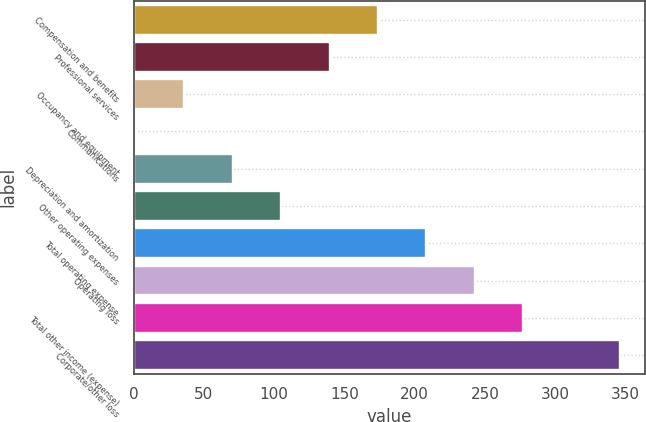<chart> <loc_0><loc_0><loc_500><loc_500><bar_chart><fcel>Compensation and benefits<fcel>Professional services<fcel>Occupancy and equipment<fcel>Communications<fcel>Depreciation and amortization<fcel>Other operating expenses<fcel>Total operating expense<fcel>Operating loss<fcel>Total other income (expense)<fcel>Corporate/other loss<nl><fcel>173.95<fcel>139.46<fcel>35.99<fcel>1.5<fcel>70.48<fcel>104.97<fcel>208.44<fcel>242.93<fcel>277.42<fcel>346.4<nl></chart> 